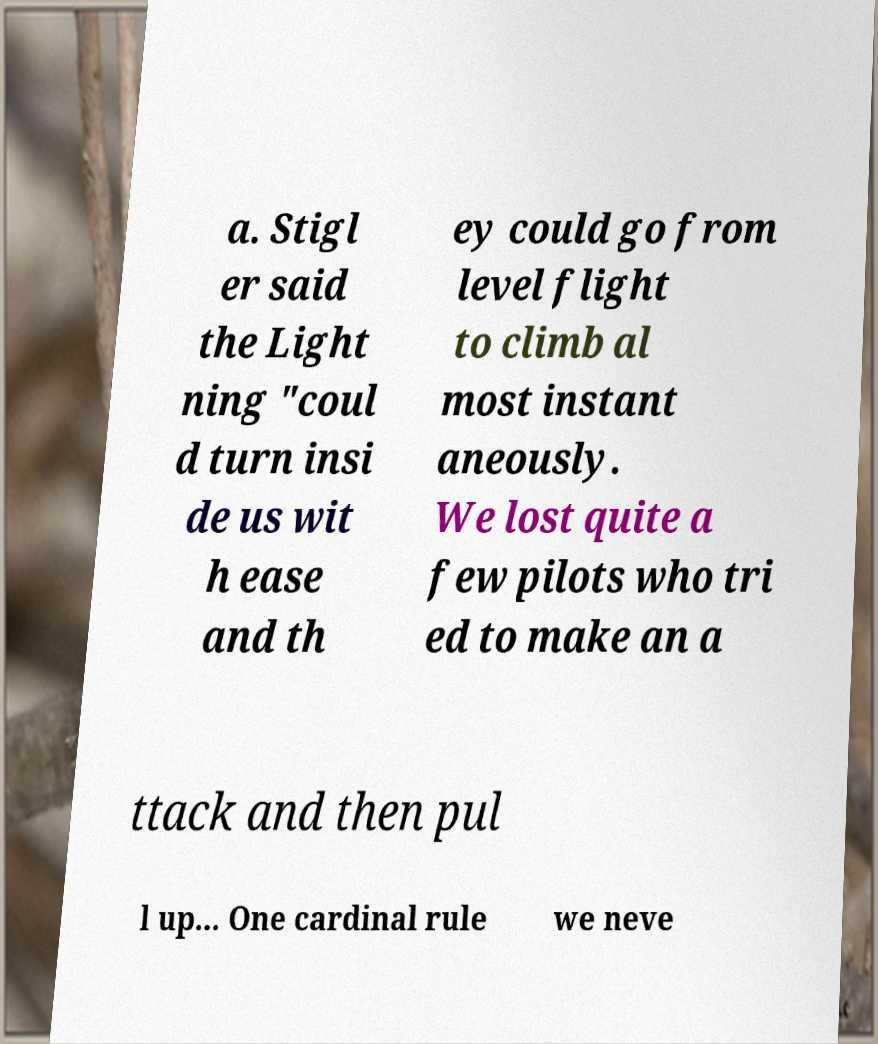Please identify and transcribe the text found in this image. a. Stigl er said the Light ning "coul d turn insi de us wit h ease and th ey could go from level flight to climb al most instant aneously. We lost quite a few pilots who tri ed to make an a ttack and then pul l up... One cardinal rule we neve 